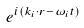<formula> <loc_0><loc_0><loc_500><loc_500>e ^ { i ( k _ { i } \cdot r - \omega _ { i } t ) }</formula> 